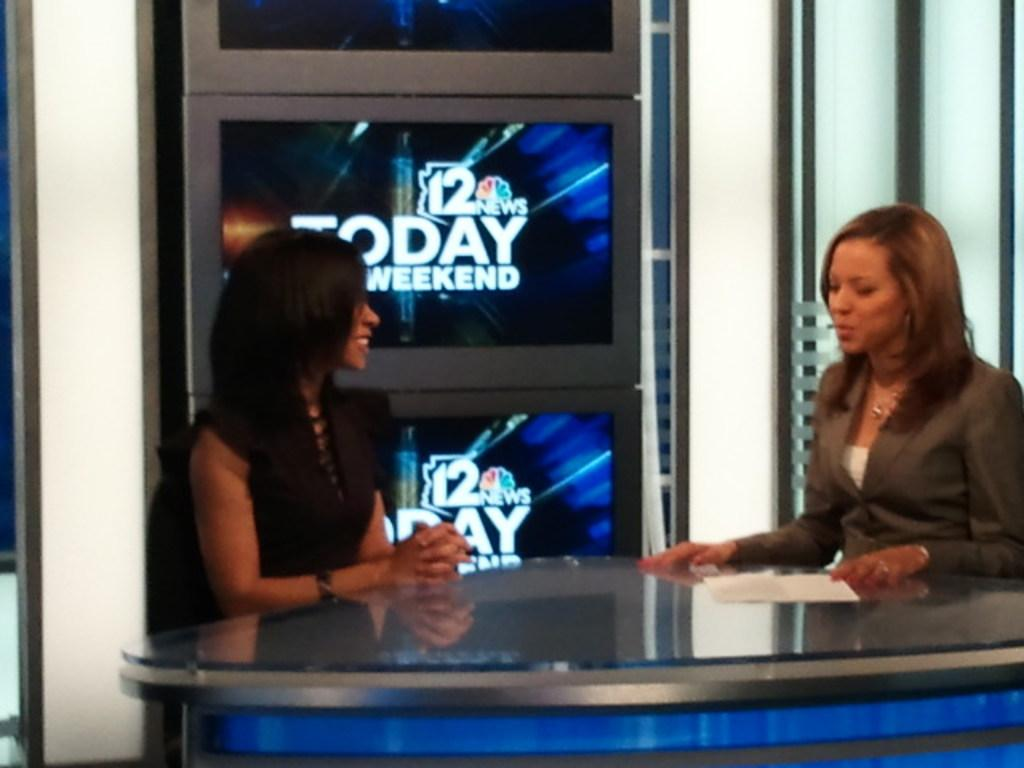<image>
Give a short and clear explanation of the subsequent image. Two female anchors engaged in a conversation on a TV set for 12 News Today Weekend edition. 